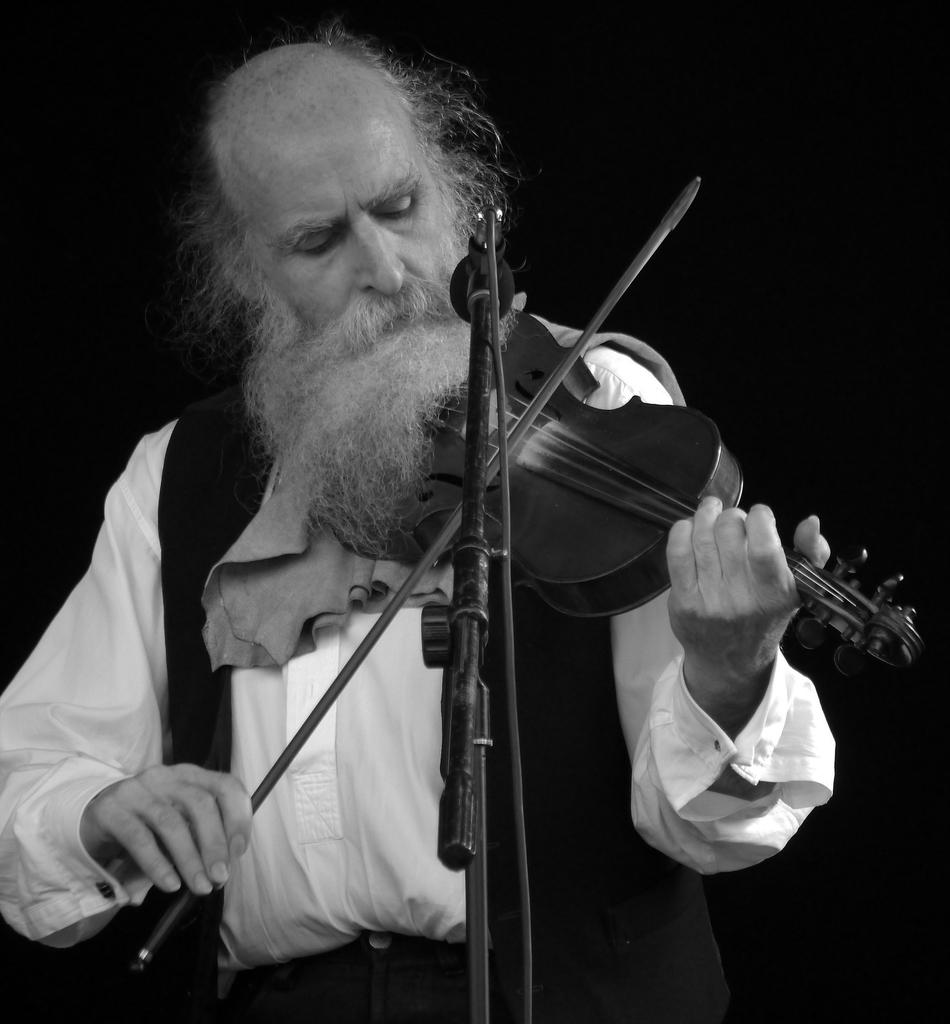What is the color scheme of the image? The image is black and white. Who is the main subject in the image? There is an old man in the image. What is the old man doing in the image? The old man is standing and playing a violin. What equipment is present in the image for amplifying sound? There is a microphone and a microphone stand in the image. What type of loaf is the old man holding in the image? There is no loaf present in the image; the old man is playing a violin. What type of wood is the violin made of in the image? The type of wood the violin is made of cannot be determined from the image, as it is in black and white. 